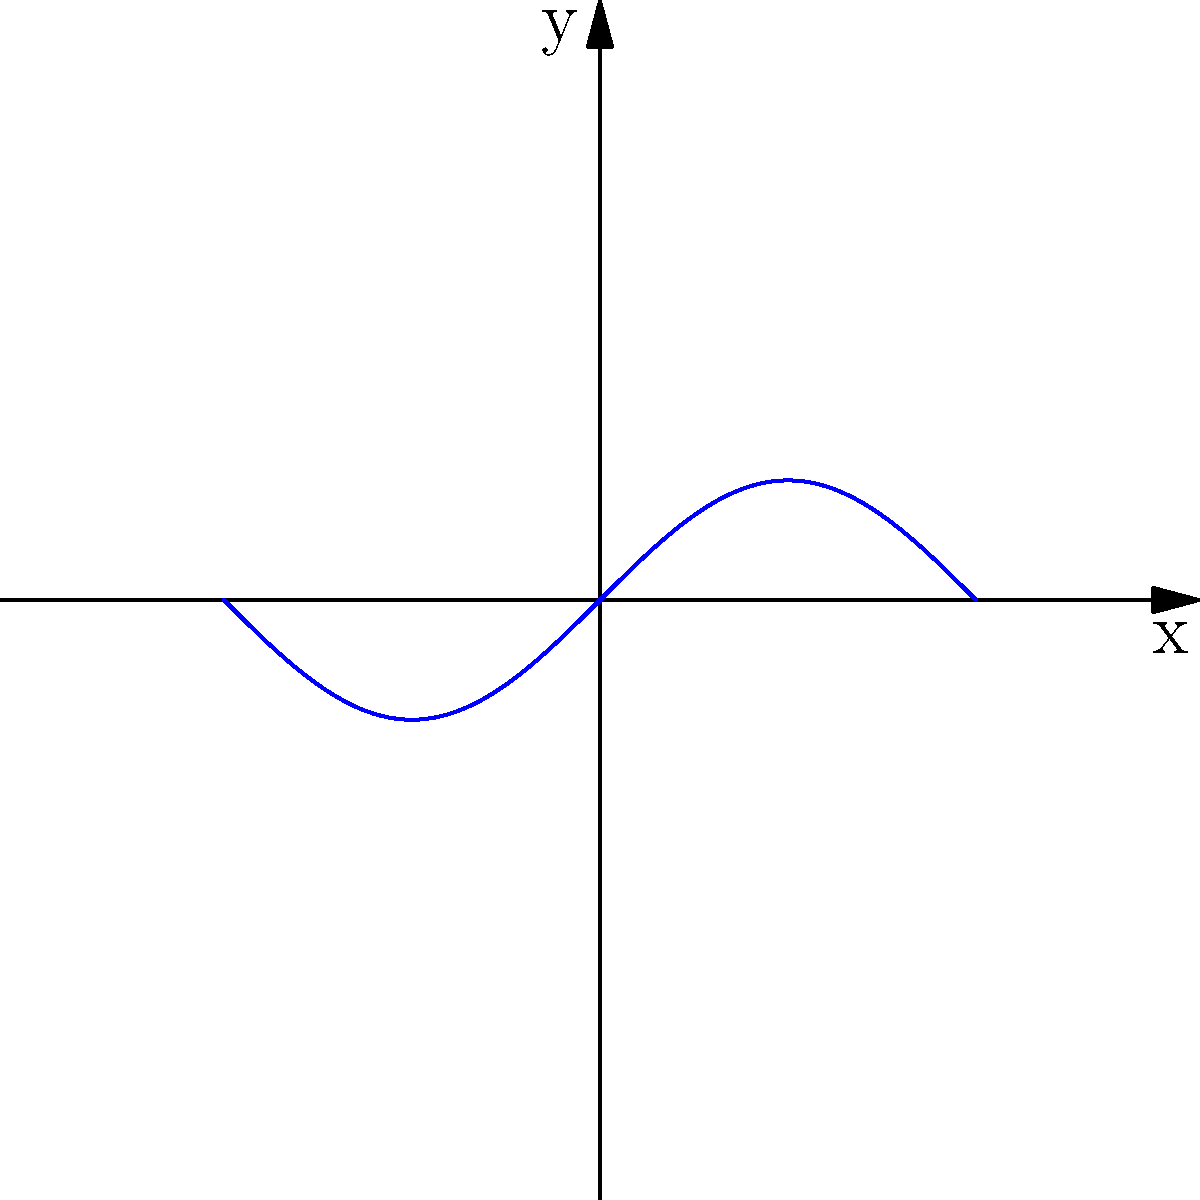In the context of scratching techniques, consider the sine wave shown in blue as a representation of a basic scratch pattern. If you wanted to create a more complex scratch by layering this pattern, how would you translate the original curve 2 units to the right to achieve the red curve? Express your answer as a transformation of the function $f(x) = \sin(x)$. To solve this problem, let's follow these steps:

1) The original function is given as $f(x) = \sin(x)$, represented by the blue curve.

2) To translate a function horizontally, we modify the input of the function. 
   - To move right, we subtract from x inside the function.
   - To move left, we add to x inside the function.

3) We want to move the curve 2 units to the right. This means we need to subtract 2 from x inside the sine function.

4) The new function will be of the form: $f(x-2) = \sin(x-2)$

5) This transformation means that for any x-coordinate on the red curve, its y-value will be the same as the y-value of the blue curve at (x-2).

6) In terms of scratching, this could represent layering the same scratch pattern slightly offset in time, creating a more complex rhythmic effect.

Therefore, the function representing the translated curve (red) is $f(x-2) = \sin(x-2)$.
Answer: $f(x-2) = \sin(x-2)$ 